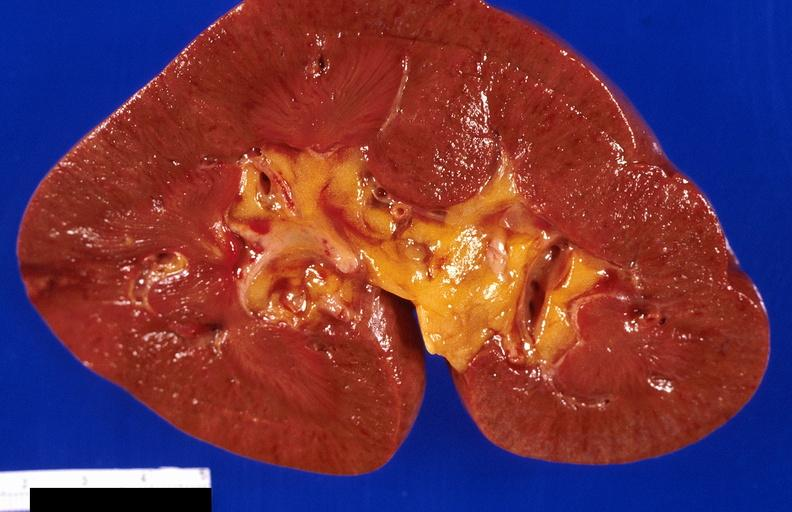does hepatobiliary show kidney, infarct?
Answer the question using a single word or phrase. No 